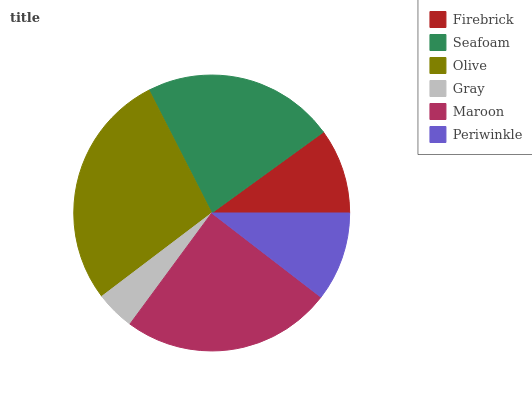Is Gray the minimum?
Answer yes or no. Yes. Is Olive the maximum?
Answer yes or no. Yes. Is Seafoam the minimum?
Answer yes or no. No. Is Seafoam the maximum?
Answer yes or no. No. Is Seafoam greater than Firebrick?
Answer yes or no. Yes. Is Firebrick less than Seafoam?
Answer yes or no. Yes. Is Firebrick greater than Seafoam?
Answer yes or no. No. Is Seafoam less than Firebrick?
Answer yes or no. No. Is Seafoam the high median?
Answer yes or no. Yes. Is Periwinkle the low median?
Answer yes or no. Yes. Is Maroon the high median?
Answer yes or no. No. Is Seafoam the low median?
Answer yes or no. No. 